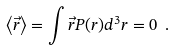Convert formula to latex. <formula><loc_0><loc_0><loc_500><loc_500>\left < { \vec { r } } \right > = \int { \vec { r } } P ( r ) d ^ { 3 } r = 0 \ .</formula> 